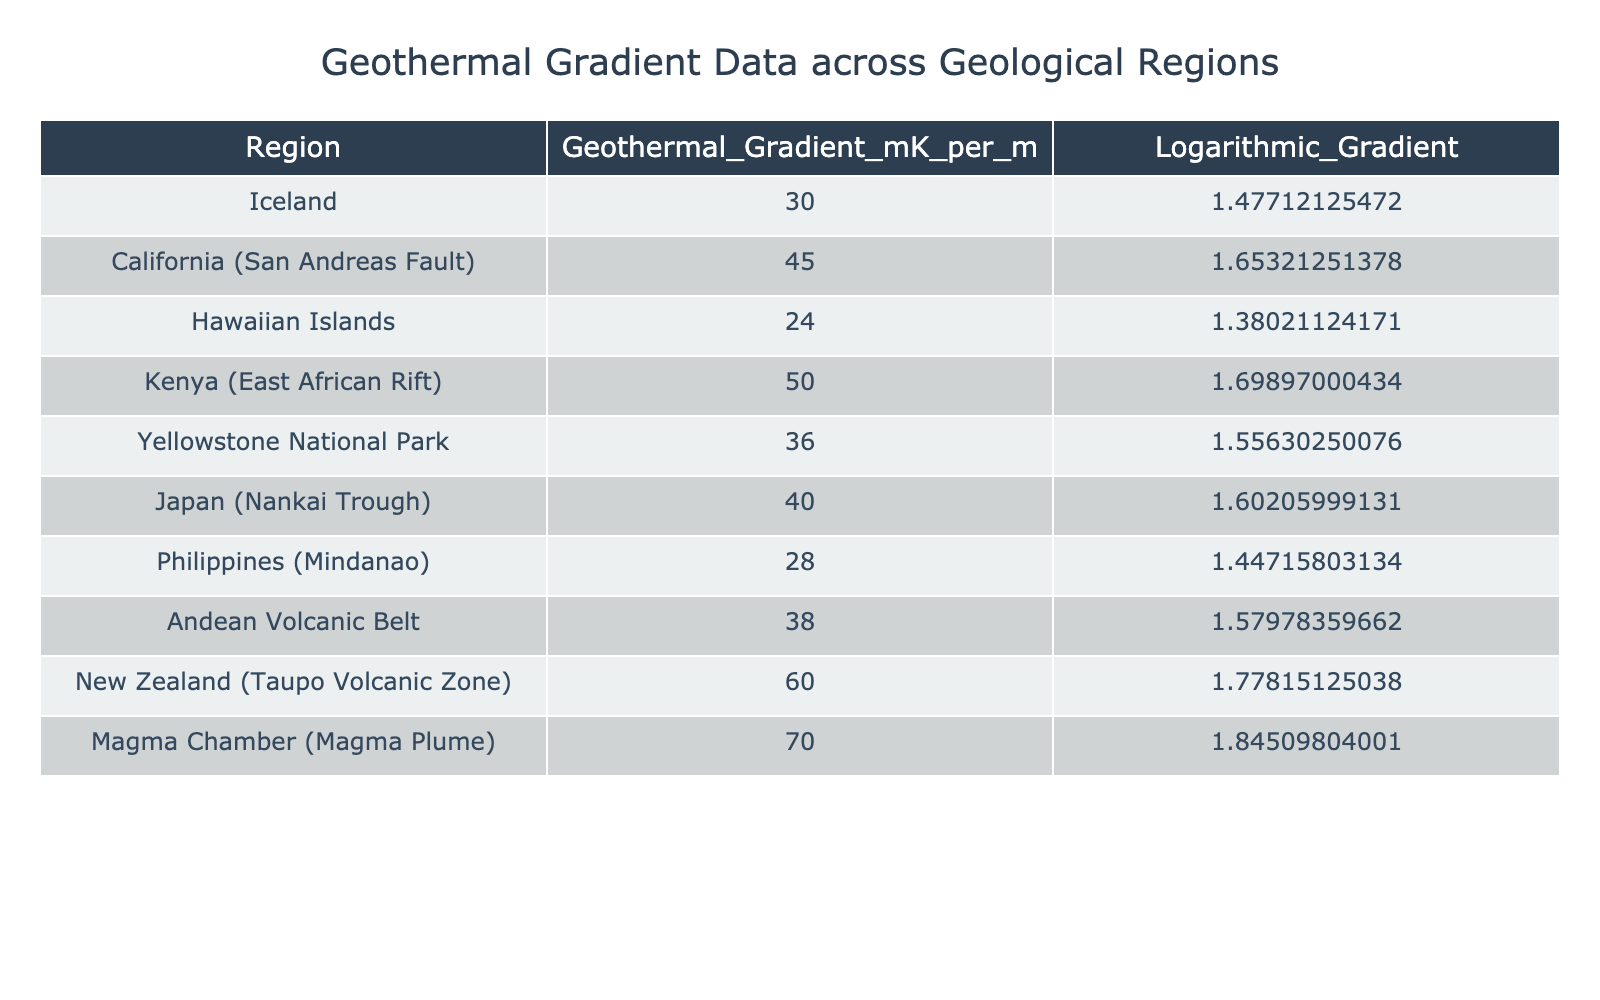What is the geothermal gradient value of the Andean Volcanic Belt? The table shows that the geothermal gradient for the Andean Volcanic Belt is listed as 38 mK per m.
Answer: 38 mK per m Which region has the highest geothermal gradient? By comparing the values in the table, the highest geothermal gradient is found in the Magma Chamber (Magma Plume) region, which has a value of 70 mK per m.
Answer: Magma Chamber (Magma Plume) Is the geothermal gradient of Hawaii greater than that of California? The geothermal gradient for Hawaii (24 mK per m) is lower than that of California (45 mK per m), making this statement false.
Answer: No What is the average geothermal gradient for regions with gradients greater than 40 mK per m? The regions with gradients greater than 40 mK per m are California (45), Kenya (50), Japan (40), New Zealand (60), and Magma Chamber (70). Adding these values gives 45 + 50 + 40 + 60 + 70 = 265. Dividing by the number of regions (5), the average is 265/5 = 53 mK per m.
Answer: 53 mK per m What is the difference in geothermal gradient between the highest and lowest values? The highest geothermal gradient is 70 mK per m (Magma Chamber) and the lowest is 24 mK per m (Hawaiian Islands). The difference is 70 - 24 = 46 mK per m.
Answer: 46 mK per m Which two regions have geothermal gradients that sum to 100 mK per m? Analyzing pairs in the table, the geothermal gradient of New Zealand (60 mK per m) and Kenya (50 mK per m) add up to 110 mK per m, but no direct pairs sum to 100 mK per m. No pairs meet this criterion.
Answer: None What is the logarithmic gradient value for Yellowstone National Park? According to the table, the logarithmic gradient for Yellowstone National Park is 1.55630250076.
Answer: 1.55630250076 Is the geothermal gradient of the Philippines higher than that of Japan? The geothermal gradient for the Philippines is 28 mK per m, whereas for Japan it is 40 mK per m, indicating that this statement is false.
Answer: No What is the geothermal gradient range across all the regions listed in the table? The highest geothermal gradient is 70 mK per m (Magma Chamber) and the lowest is 24 mK per m (Hawaiian Islands). Therefore, the range is from 24 to 70 mK per m, which can be calculated as 70 - 24 = 46 mK per m.
Answer: 46 mK per m 